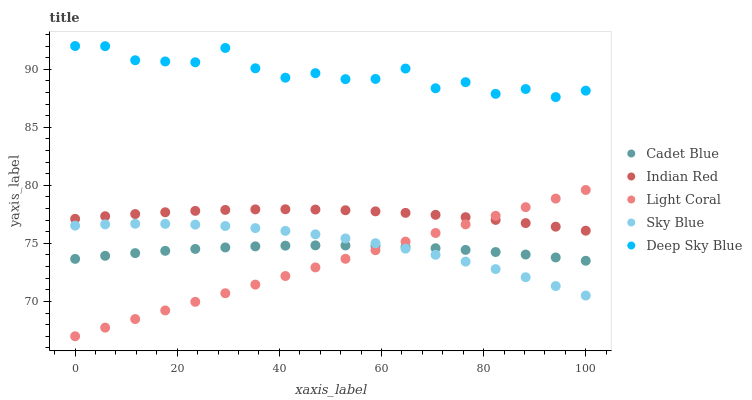Does Light Coral have the minimum area under the curve?
Answer yes or no. Yes. Does Deep Sky Blue have the maximum area under the curve?
Answer yes or no. Yes. Does Sky Blue have the minimum area under the curve?
Answer yes or no. No. Does Sky Blue have the maximum area under the curve?
Answer yes or no. No. Is Light Coral the smoothest?
Answer yes or no. Yes. Is Deep Sky Blue the roughest?
Answer yes or no. Yes. Is Sky Blue the smoothest?
Answer yes or no. No. Is Sky Blue the roughest?
Answer yes or no. No. Does Light Coral have the lowest value?
Answer yes or no. Yes. Does Sky Blue have the lowest value?
Answer yes or no. No. Does Deep Sky Blue have the highest value?
Answer yes or no. Yes. Does Sky Blue have the highest value?
Answer yes or no. No. Is Cadet Blue less than Indian Red?
Answer yes or no. Yes. Is Deep Sky Blue greater than Cadet Blue?
Answer yes or no. Yes. Does Light Coral intersect Indian Red?
Answer yes or no. Yes. Is Light Coral less than Indian Red?
Answer yes or no. No. Is Light Coral greater than Indian Red?
Answer yes or no. No. Does Cadet Blue intersect Indian Red?
Answer yes or no. No. 